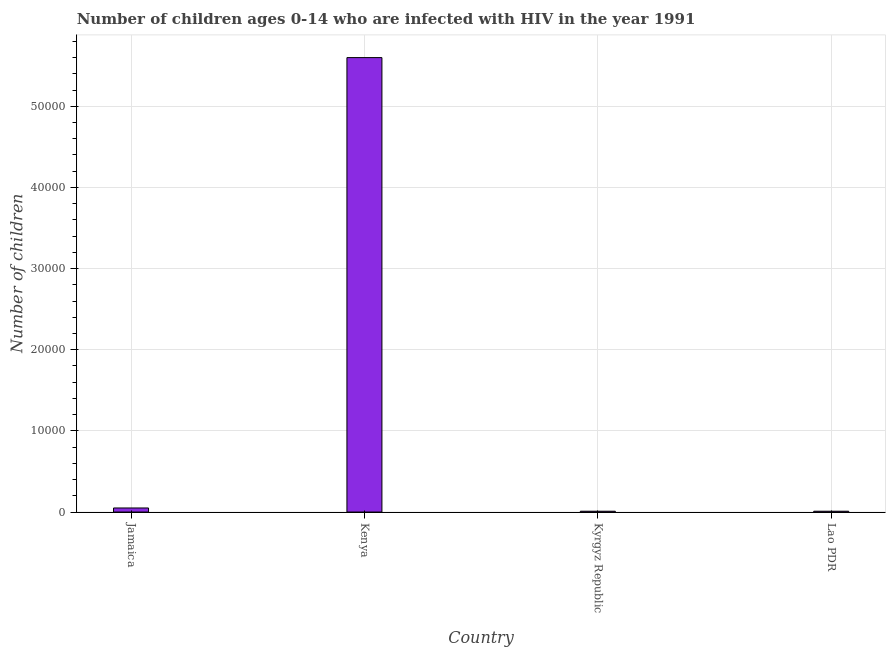Does the graph contain grids?
Offer a very short reply. Yes. What is the title of the graph?
Ensure brevity in your answer.  Number of children ages 0-14 who are infected with HIV in the year 1991. What is the label or title of the X-axis?
Make the answer very short. Country. What is the label or title of the Y-axis?
Your response must be concise. Number of children. Across all countries, what is the maximum number of children living with hiv?
Ensure brevity in your answer.  5.60e+04. Across all countries, what is the minimum number of children living with hiv?
Your answer should be compact. 100. In which country was the number of children living with hiv maximum?
Offer a very short reply. Kenya. In which country was the number of children living with hiv minimum?
Ensure brevity in your answer.  Kyrgyz Republic. What is the sum of the number of children living with hiv?
Provide a succinct answer. 5.67e+04. What is the difference between the number of children living with hiv in Jamaica and Kenya?
Ensure brevity in your answer.  -5.55e+04. What is the average number of children living with hiv per country?
Keep it short and to the point. 1.42e+04. What is the median number of children living with hiv?
Your answer should be very brief. 300. In how many countries, is the number of children living with hiv greater than 24000 ?
Provide a short and direct response. 1. What is the ratio of the number of children living with hiv in Kyrgyz Republic to that in Lao PDR?
Your response must be concise. 1. Is the number of children living with hiv in Jamaica less than that in Lao PDR?
Your answer should be very brief. No. What is the difference between the highest and the second highest number of children living with hiv?
Your answer should be very brief. 5.55e+04. What is the difference between the highest and the lowest number of children living with hiv?
Your response must be concise. 5.59e+04. How many bars are there?
Ensure brevity in your answer.  4. Are all the bars in the graph horizontal?
Give a very brief answer. No. How many countries are there in the graph?
Provide a succinct answer. 4. Are the values on the major ticks of Y-axis written in scientific E-notation?
Keep it short and to the point. No. What is the Number of children of Kenya?
Offer a very short reply. 5.60e+04. What is the Number of children of Kyrgyz Republic?
Provide a short and direct response. 100. What is the difference between the Number of children in Jamaica and Kenya?
Offer a very short reply. -5.55e+04. What is the difference between the Number of children in Jamaica and Kyrgyz Republic?
Your response must be concise. 400. What is the difference between the Number of children in Jamaica and Lao PDR?
Your response must be concise. 400. What is the difference between the Number of children in Kenya and Kyrgyz Republic?
Your answer should be compact. 5.59e+04. What is the difference between the Number of children in Kenya and Lao PDR?
Your answer should be compact. 5.59e+04. What is the ratio of the Number of children in Jamaica to that in Kenya?
Give a very brief answer. 0.01. What is the ratio of the Number of children in Kenya to that in Kyrgyz Republic?
Provide a short and direct response. 560. What is the ratio of the Number of children in Kenya to that in Lao PDR?
Provide a short and direct response. 560. What is the ratio of the Number of children in Kyrgyz Republic to that in Lao PDR?
Provide a short and direct response. 1. 